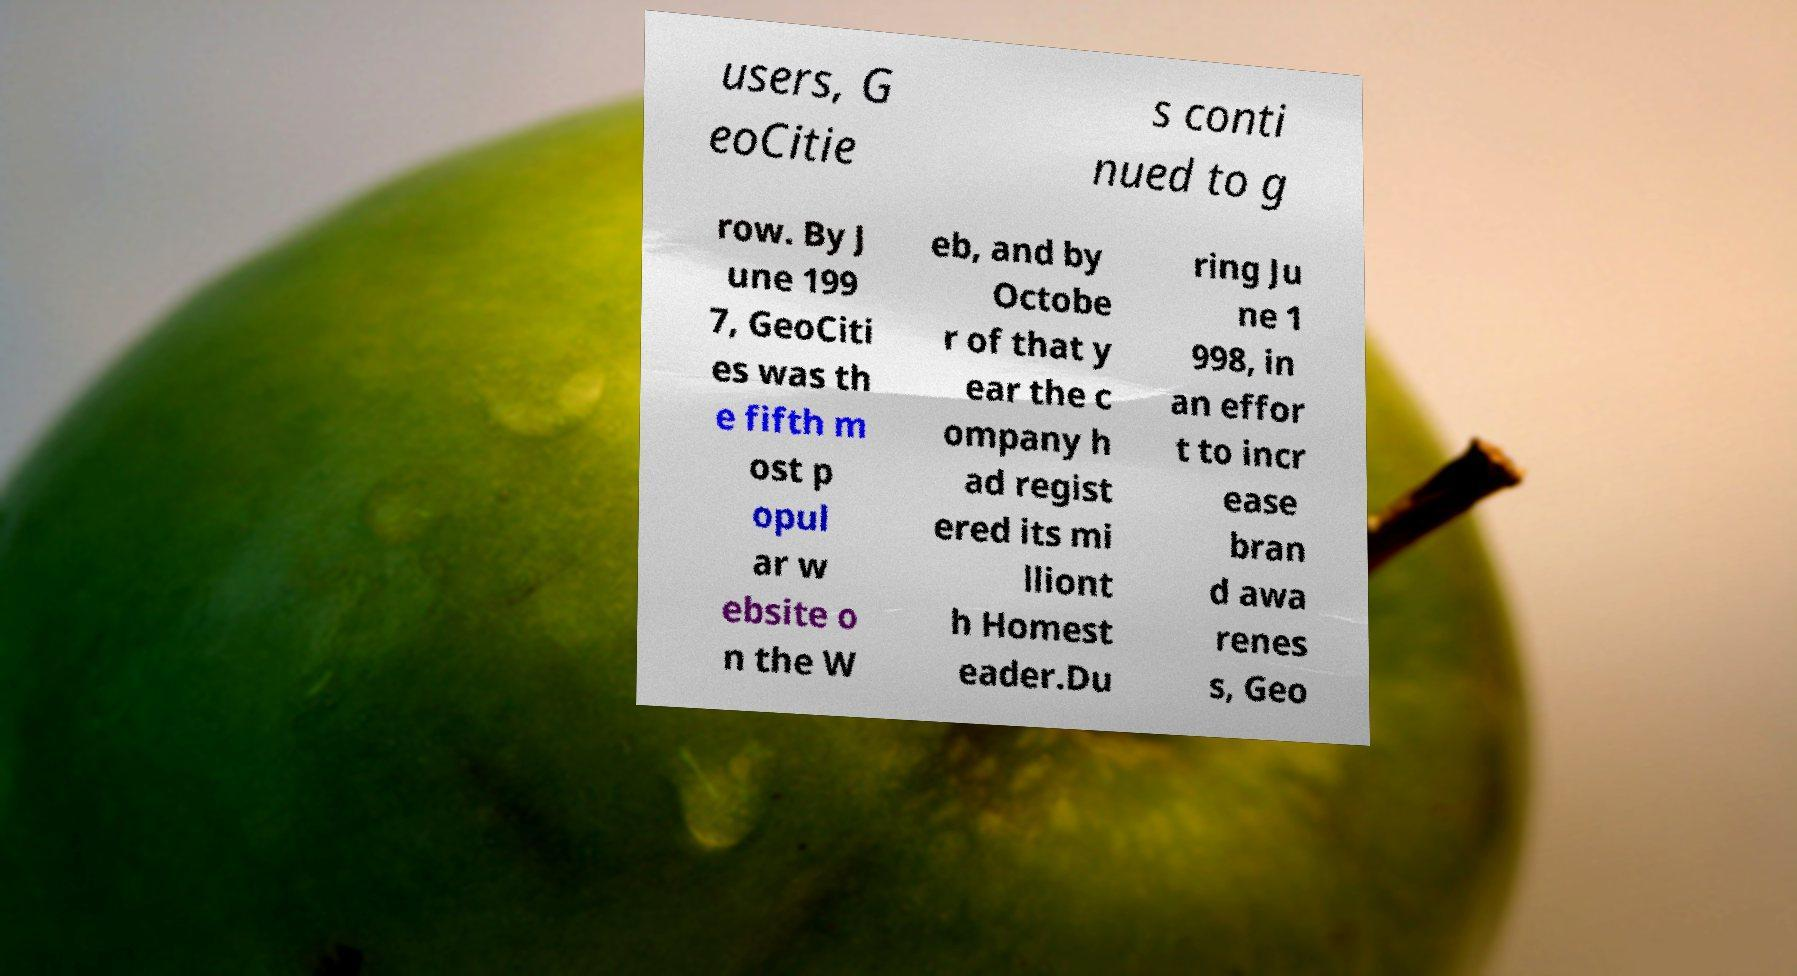I need the written content from this picture converted into text. Can you do that? users, G eoCitie s conti nued to g row. By J une 199 7, GeoCiti es was th e fifth m ost p opul ar w ebsite o n the W eb, and by Octobe r of that y ear the c ompany h ad regist ered its mi lliont h Homest eader.Du ring Ju ne 1 998, in an effor t to incr ease bran d awa renes s, Geo 